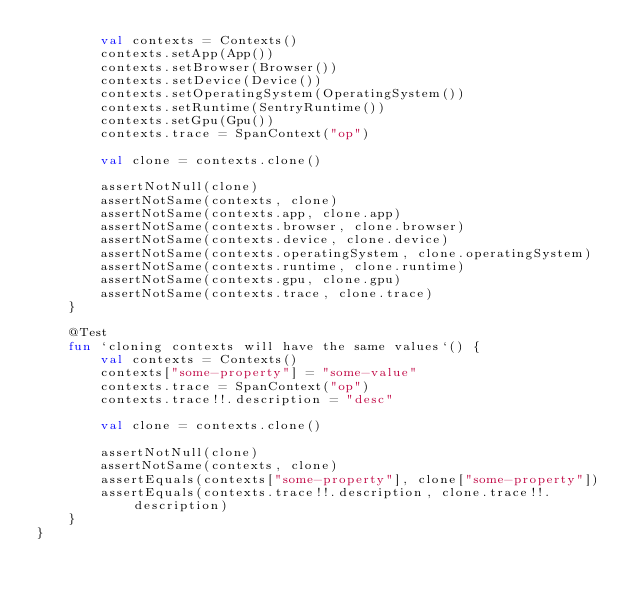<code> <loc_0><loc_0><loc_500><loc_500><_Kotlin_>        val contexts = Contexts()
        contexts.setApp(App())
        contexts.setBrowser(Browser())
        contexts.setDevice(Device())
        contexts.setOperatingSystem(OperatingSystem())
        contexts.setRuntime(SentryRuntime())
        contexts.setGpu(Gpu())
        contexts.trace = SpanContext("op")

        val clone = contexts.clone()

        assertNotNull(clone)
        assertNotSame(contexts, clone)
        assertNotSame(contexts.app, clone.app)
        assertNotSame(contexts.browser, clone.browser)
        assertNotSame(contexts.device, clone.device)
        assertNotSame(contexts.operatingSystem, clone.operatingSystem)
        assertNotSame(contexts.runtime, clone.runtime)
        assertNotSame(contexts.gpu, clone.gpu)
        assertNotSame(contexts.trace, clone.trace)
    }

    @Test
    fun `cloning contexts will have the same values`() {
        val contexts = Contexts()
        contexts["some-property"] = "some-value"
        contexts.trace = SpanContext("op")
        contexts.trace!!.description = "desc"

        val clone = contexts.clone()

        assertNotNull(clone)
        assertNotSame(contexts, clone)
        assertEquals(contexts["some-property"], clone["some-property"])
        assertEquals(contexts.trace!!.description, clone.trace!!.description)
    }
}
</code> 